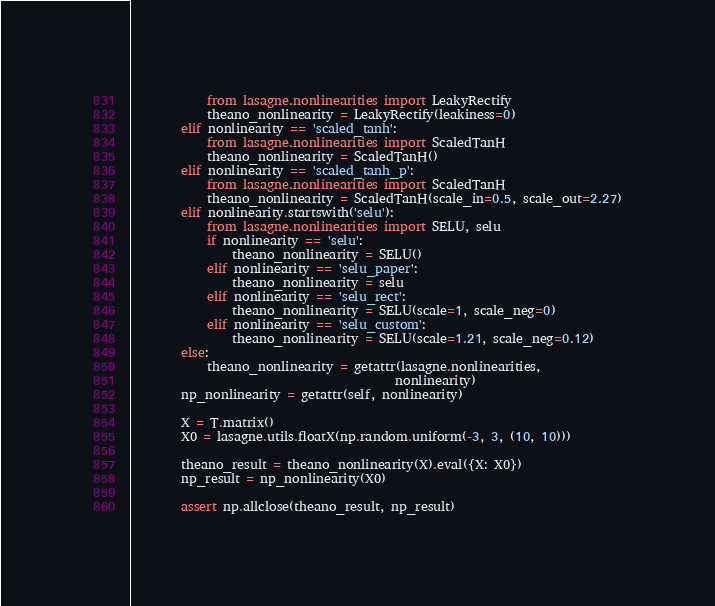<code> <loc_0><loc_0><loc_500><loc_500><_Python_>            from lasagne.nonlinearities import LeakyRectify
            theano_nonlinearity = LeakyRectify(leakiness=0)
        elif nonlinearity == 'scaled_tanh':
            from lasagne.nonlinearities import ScaledTanH
            theano_nonlinearity = ScaledTanH()
        elif nonlinearity == 'scaled_tanh_p':
            from lasagne.nonlinearities import ScaledTanH
            theano_nonlinearity = ScaledTanH(scale_in=0.5, scale_out=2.27)
        elif nonlinearity.startswith('selu'):
            from lasagne.nonlinearities import SELU, selu
            if nonlinearity == 'selu':
                theano_nonlinearity = SELU()
            elif nonlinearity == 'selu_paper':
                theano_nonlinearity = selu
            elif nonlinearity == 'selu_rect':
                theano_nonlinearity = SELU(scale=1, scale_neg=0)
            elif nonlinearity == 'selu_custom':
                theano_nonlinearity = SELU(scale=1.21, scale_neg=0.12)
        else:
            theano_nonlinearity = getattr(lasagne.nonlinearities,
                                          nonlinearity)
        np_nonlinearity = getattr(self, nonlinearity)

        X = T.matrix()
        X0 = lasagne.utils.floatX(np.random.uniform(-3, 3, (10, 10)))

        theano_result = theano_nonlinearity(X).eval({X: X0})
        np_result = np_nonlinearity(X0)

        assert np.allclose(theano_result, np_result)
</code> 